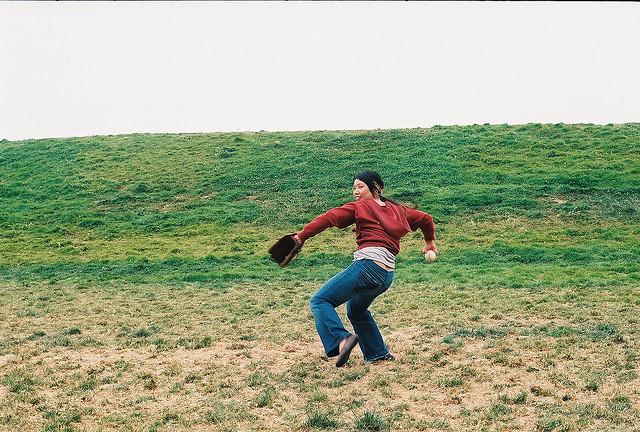What is the woman wearing?
Keep it brief. Sweater. What kind of sport is this?
Write a very short answer. Baseball. Is she wearing tennis shoes?
Write a very short answer. No. Is the woman expecting rain?
Give a very brief answer. No. Is the woman about to throw the ball?
Concise answer only. Yes. What is in the background of this photo?
Answer briefly. Grass. How many flags are seen?
Keep it brief. 0. What is the little girl doing at the park?
Concise answer only. Throwing ball. Sunny or overcast?
Quick response, please. Overcast. Is this girl playing an organized team activity?
Concise answer only. No. What is the woman holding in her hands?
Concise answer only. Ball. What is the woman holding in her right hand?
Give a very brief answer. Baseball. 